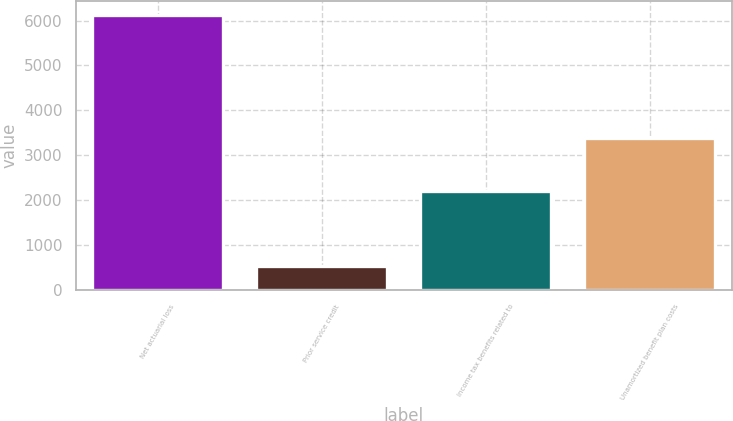<chart> <loc_0><loc_0><loc_500><loc_500><bar_chart><fcel>Net actuarial loss<fcel>Prior service credit<fcel>Income tax benefits related to<fcel>Unamortized benefit plan costs<nl><fcel>6131<fcel>537<fcel>2215<fcel>3379<nl></chart> 